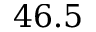Convert formula to latex. <formula><loc_0><loc_0><loc_500><loc_500>4 6 . 5</formula> 